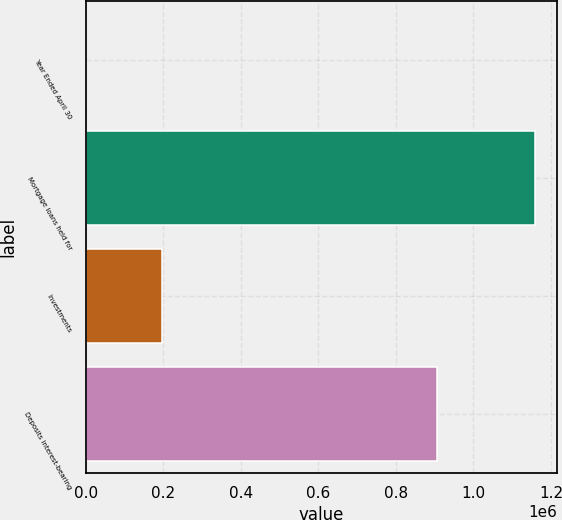Convert chart to OTSL. <chart><loc_0><loc_0><loc_500><loc_500><bar_chart><fcel>Year Ended April 30<fcel>Mortgage loans held for<fcel>Investments<fcel>Deposits interest-bearing<nl><fcel>2008<fcel>1.15736e+06<fcel>196262<fcel>904836<nl></chart> 